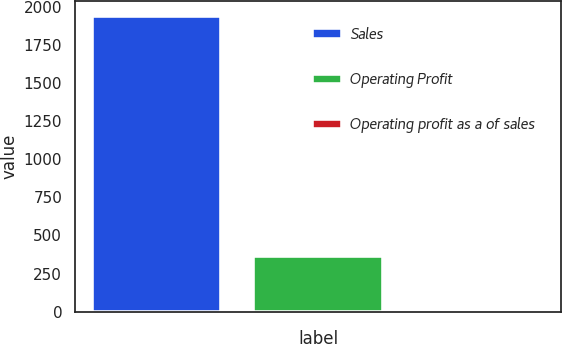<chart> <loc_0><loc_0><loc_500><loc_500><bar_chart><fcel>Sales<fcel>Operating Profit<fcel>Operating profit as a of sales<nl><fcel>1939.7<fcel>362.6<fcel>18.7<nl></chart> 